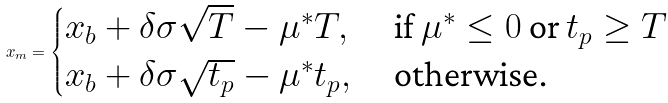Convert formula to latex. <formula><loc_0><loc_0><loc_500><loc_500>x _ { m } = \begin{cases} x _ { b } + \delta \sigma \sqrt { T } - \mu ^ { * } T , & \text { if $\mu^{*} \leq 0$ or $t_{p} \geq T$ } \\ x _ { b } + \delta \sigma \sqrt { t _ { p } } - \mu ^ { * } t _ { p } , & \text { otherwise.} \end{cases}</formula> 